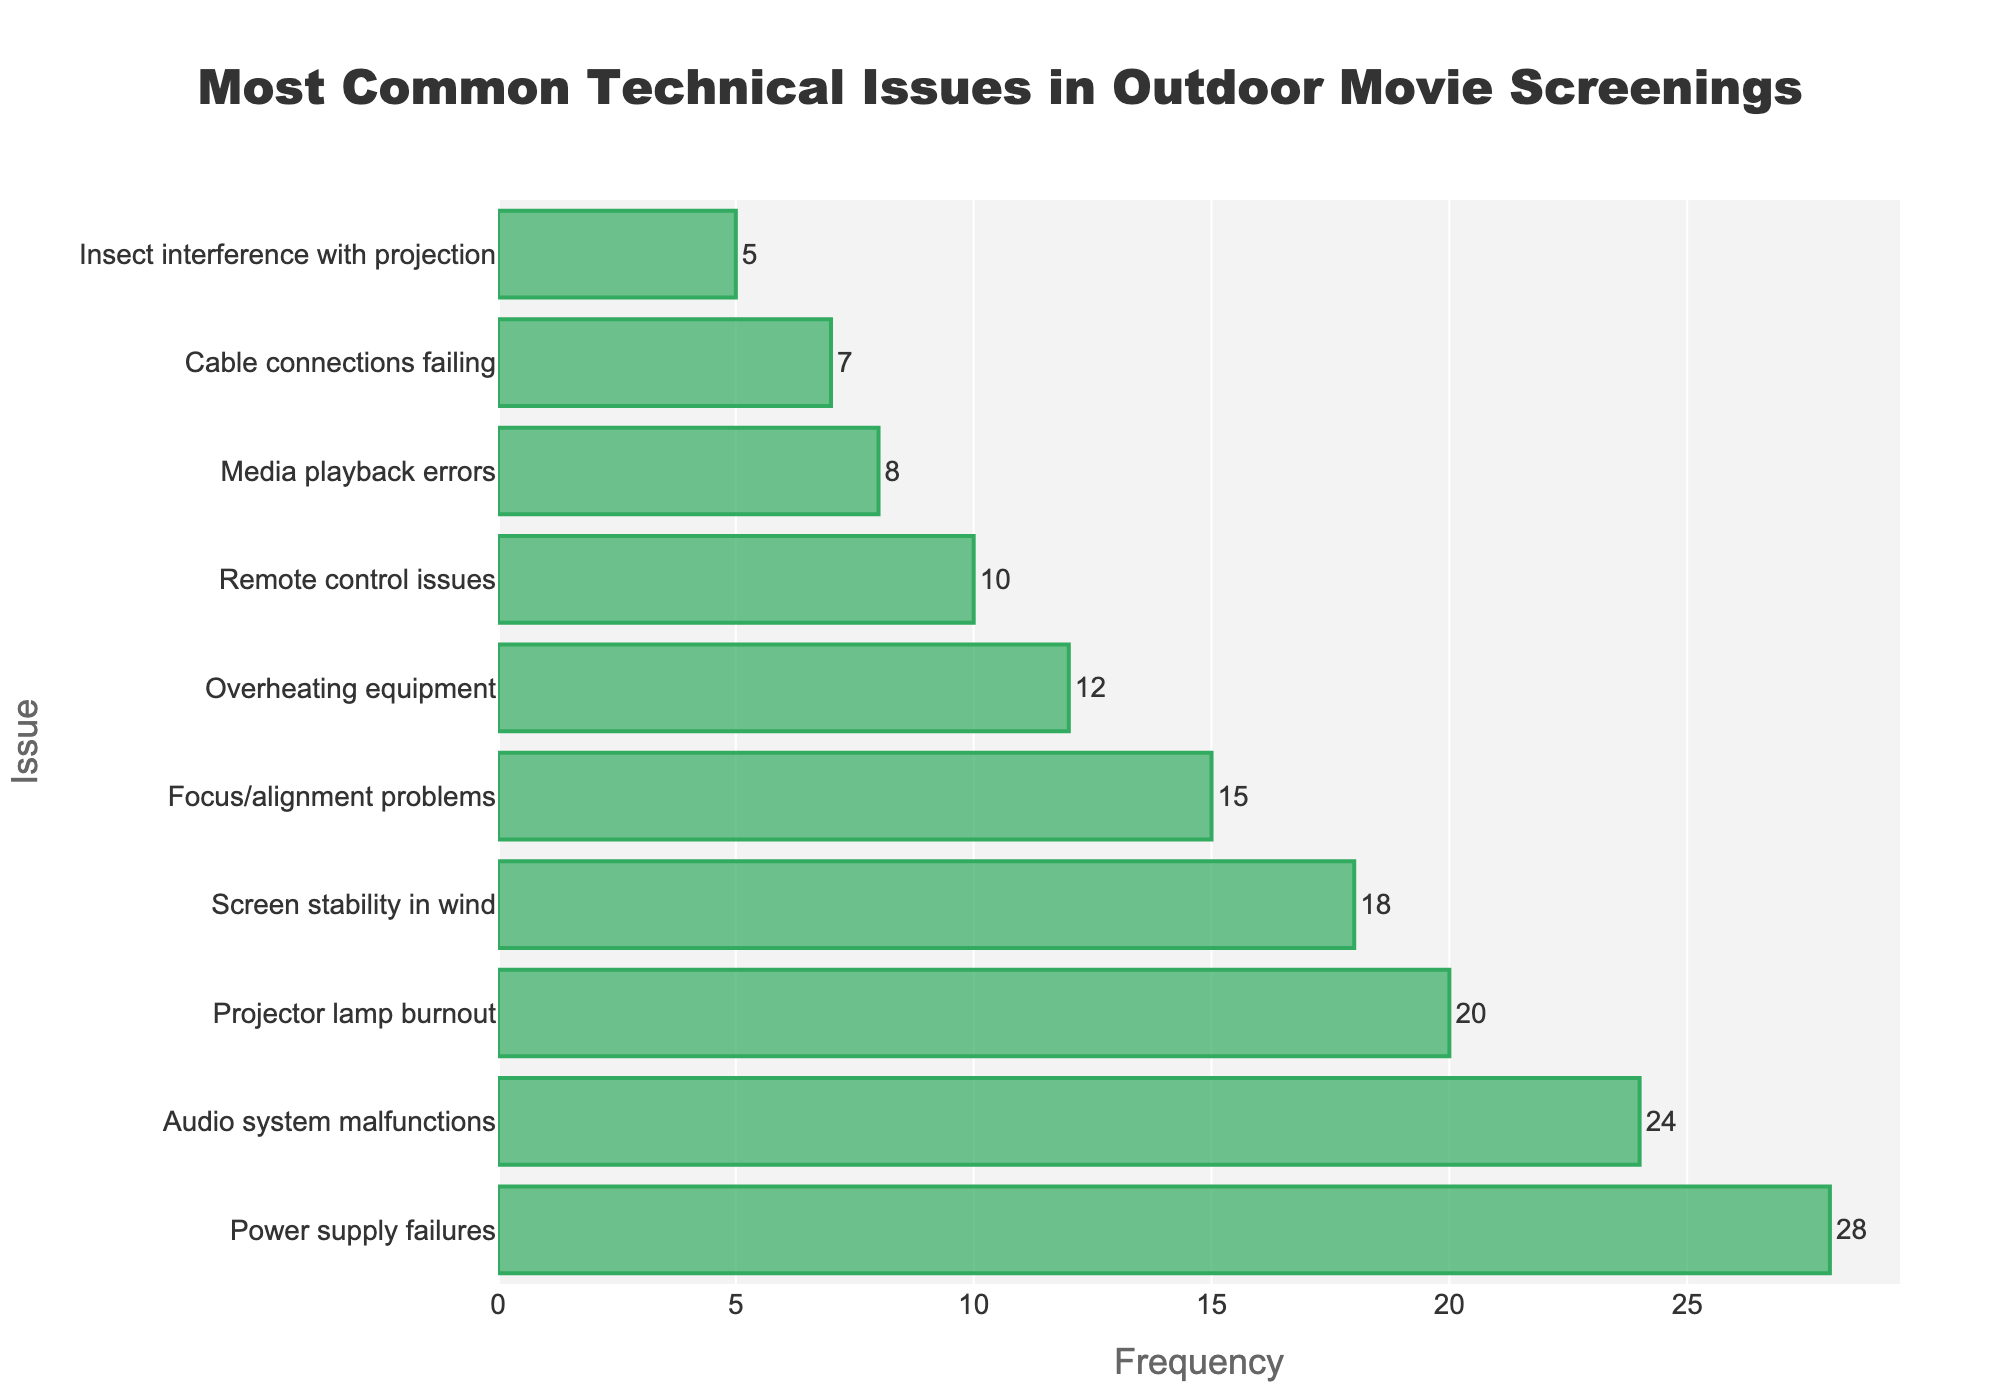What's the most common technical issue during outdoor movie screenings? The bar chart shows the frequency of each issue. The highest bar represents the most common issue.
Answer: Power supply failures Which issue is more frequent: Projector lamp burnout or Focus/alignment problems? Compare the heights of the bars corresponding to 'Projector lamp burnout' and 'Focus/alignment problems'. The 'Projector lamp burnout' bar is taller.
Answer: Projector lamp burnout What is the combined frequency of Overheating equipment and Cable connections failing? Add the frequencies of 'Overheating equipment' (12) and 'Cable connections failing' (7).
Answer: 19 How much more frequent are Audio system malfunctions compared to Media playback errors? Subtract the frequency of 'Media playback errors' (8) from 'Audio system malfunctions' (24).
Answer: 16 Is Screen stability in wind a more frequent issue than Remote control issues? Compare the bar heights of 'Screen stability in wind' and 'Remote control issues'. The 'Screen stability in wind' bar is taller.
Answer: Yes Which issue has the least frequency? Observe the shortest bar on the chart, which represents the least frequent issue.
Answer: Insect interference with projection How many issues have a frequency greater than 10? Count the number of bars with frequencies higher than 10. There are 6 such bars.
Answer: 6 What is the average frequency of all issues? Sum all frequencies (28+24+20+18+15+12+10+8+7+5 = 147) and divide by the number of issues (10).
Answer: 14.7 By how much does the frequency of Power supply failures exceed the frequency of Focus/alignment problems? Subtract the frequency of 'Focus/alignment problems' (15) from 'Power supply failures' (28).
Answer: 13 